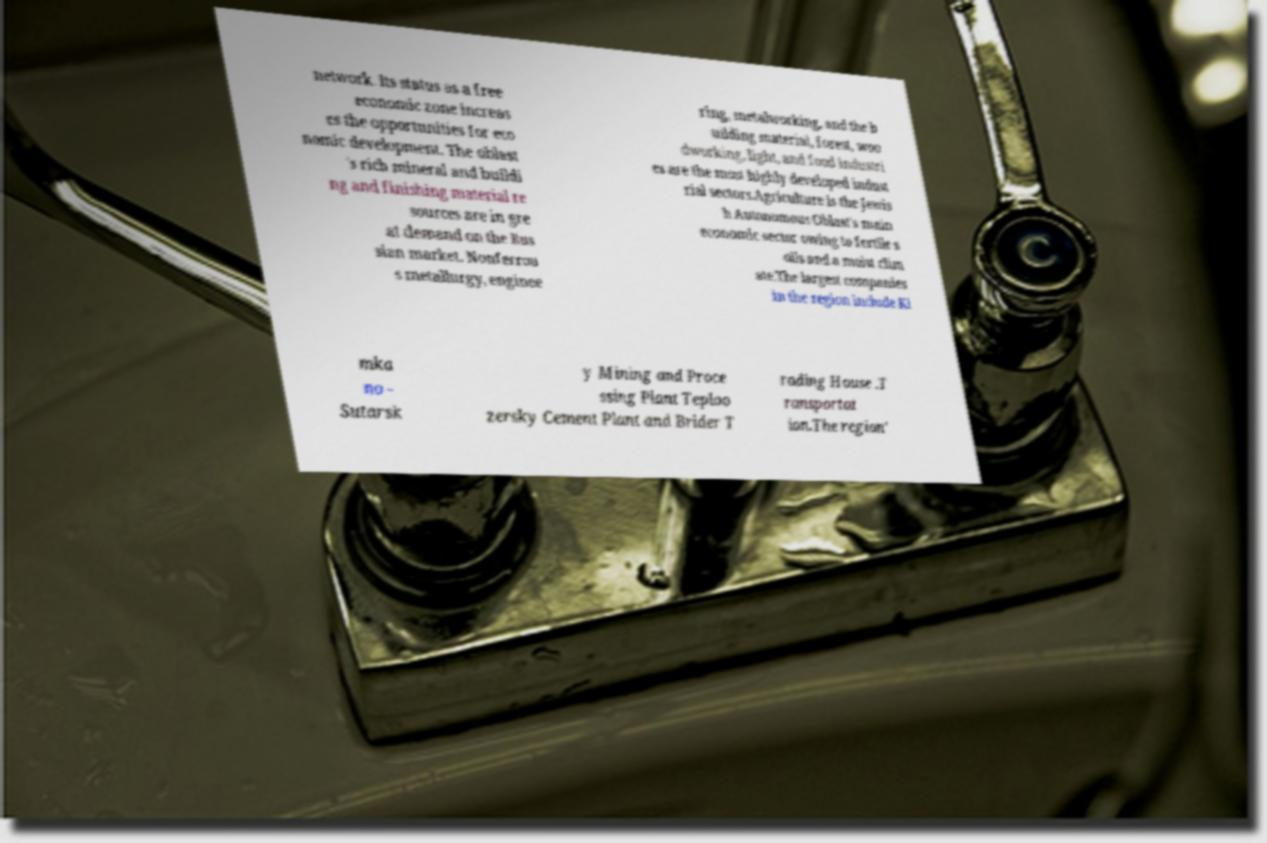Please read and relay the text visible in this image. What does it say? network. Its status as a free economic zone increas es the opportunities for eco nomic development. The oblast 's rich mineral and buildi ng and finishing material re sources are in gre at demand on the Rus sian market. Nonferrou s metallurgy, enginee ring, metalworking, and the b uilding material, forest, woo dworking, light, and food industri es are the most highly developed indust rial sectors.Agriculture is the Jewis h Autonomous Oblast's main economic sector owing to fertile s oils and a moist clim ate.The largest companies in the region include Ki mka no - Sutarsk y Mining and Proce ssing Plant Teploo zersky Cement Plant and Brider T rading House .T ransportat ion.The region' 